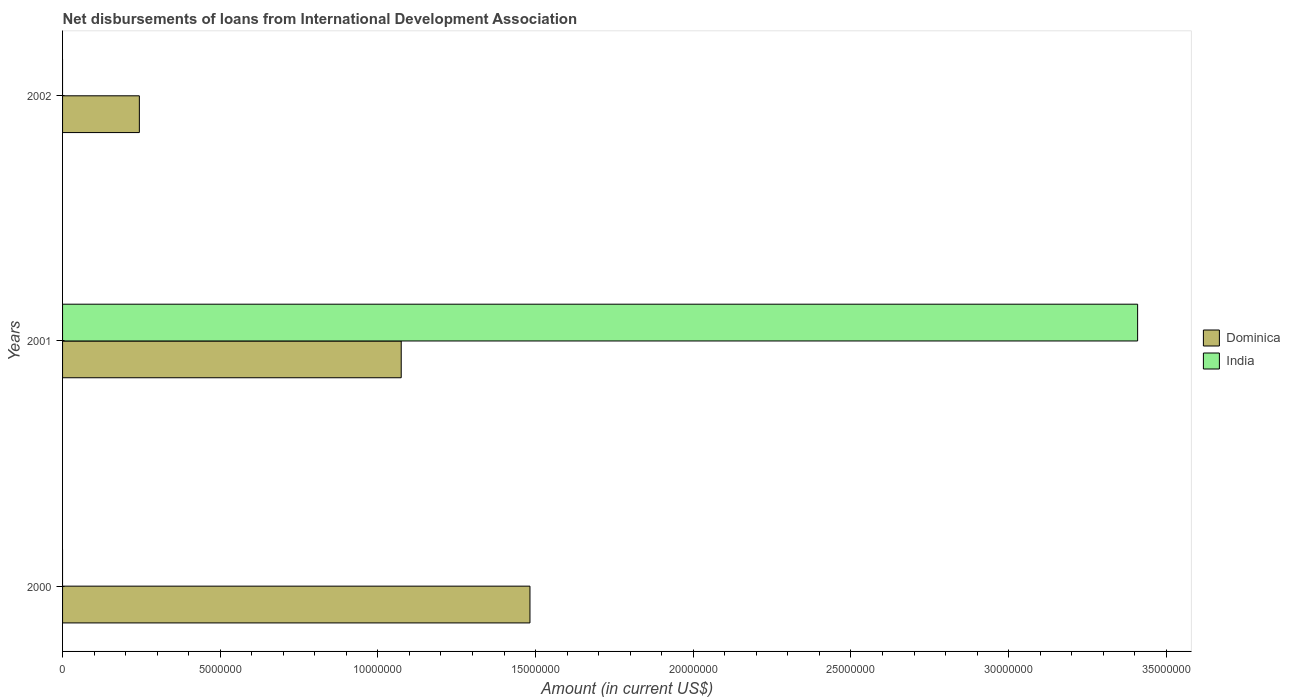How many different coloured bars are there?
Give a very brief answer. 2. How many bars are there on the 2nd tick from the top?
Make the answer very short. 2. What is the amount of loans disbursed in Dominica in 2001?
Provide a succinct answer. 1.07e+07. Across all years, what is the maximum amount of loans disbursed in India?
Ensure brevity in your answer.  3.41e+07. Across all years, what is the minimum amount of loans disbursed in India?
Provide a succinct answer. 0. In which year was the amount of loans disbursed in India maximum?
Your response must be concise. 2001. What is the total amount of loans disbursed in Dominica in the graph?
Make the answer very short. 2.80e+07. What is the difference between the amount of loans disbursed in Dominica in 2000 and that in 2001?
Your answer should be compact. 4.08e+06. What is the difference between the amount of loans disbursed in India in 2001 and the amount of loans disbursed in Dominica in 2002?
Your answer should be compact. 3.17e+07. What is the average amount of loans disbursed in India per year?
Make the answer very short. 1.14e+07. In the year 2001, what is the difference between the amount of loans disbursed in Dominica and amount of loans disbursed in India?
Provide a succinct answer. -2.34e+07. In how many years, is the amount of loans disbursed in Dominica greater than 5000000 US$?
Offer a very short reply. 2. What is the ratio of the amount of loans disbursed in Dominica in 2001 to that in 2002?
Your answer should be compact. 4.41. Is the amount of loans disbursed in Dominica in 2000 less than that in 2002?
Provide a succinct answer. No. What is the difference between the highest and the second highest amount of loans disbursed in Dominica?
Offer a very short reply. 4.08e+06. What is the difference between the highest and the lowest amount of loans disbursed in Dominica?
Offer a terse response. 1.24e+07. In how many years, is the amount of loans disbursed in Dominica greater than the average amount of loans disbursed in Dominica taken over all years?
Give a very brief answer. 2. How many years are there in the graph?
Your answer should be very brief. 3. What is the difference between two consecutive major ticks on the X-axis?
Ensure brevity in your answer.  5.00e+06. Does the graph contain any zero values?
Your answer should be very brief. Yes. Where does the legend appear in the graph?
Ensure brevity in your answer.  Center right. What is the title of the graph?
Your answer should be very brief. Net disbursements of loans from International Development Association. What is the Amount (in current US$) of Dominica in 2000?
Make the answer very short. 1.48e+07. What is the Amount (in current US$) in Dominica in 2001?
Your answer should be very brief. 1.07e+07. What is the Amount (in current US$) in India in 2001?
Offer a very short reply. 3.41e+07. What is the Amount (in current US$) of Dominica in 2002?
Your answer should be compact. 2.44e+06. What is the Amount (in current US$) in India in 2002?
Your response must be concise. 0. Across all years, what is the maximum Amount (in current US$) of Dominica?
Your answer should be compact. 1.48e+07. Across all years, what is the maximum Amount (in current US$) of India?
Offer a very short reply. 3.41e+07. Across all years, what is the minimum Amount (in current US$) in Dominica?
Ensure brevity in your answer.  2.44e+06. What is the total Amount (in current US$) of Dominica in the graph?
Ensure brevity in your answer.  2.80e+07. What is the total Amount (in current US$) of India in the graph?
Provide a succinct answer. 3.41e+07. What is the difference between the Amount (in current US$) in Dominica in 2000 and that in 2001?
Your answer should be very brief. 4.08e+06. What is the difference between the Amount (in current US$) of Dominica in 2000 and that in 2002?
Provide a succinct answer. 1.24e+07. What is the difference between the Amount (in current US$) in Dominica in 2001 and that in 2002?
Provide a short and direct response. 8.30e+06. What is the difference between the Amount (in current US$) in Dominica in 2000 and the Amount (in current US$) in India in 2001?
Keep it short and to the point. -1.93e+07. What is the average Amount (in current US$) in Dominica per year?
Give a very brief answer. 9.33e+06. What is the average Amount (in current US$) of India per year?
Your answer should be compact. 1.14e+07. In the year 2001, what is the difference between the Amount (in current US$) of Dominica and Amount (in current US$) of India?
Offer a very short reply. -2.34e+07. What is the ratio of the Amount (in current US$) in Dominica in 2000 to that in 2001?
Offer a very short reply. 1.38. What is the ratio of the Amount (in current US$) of Dominica in 2000 to that in 2002?
Give a very brief answer. 6.09. What is the ratio of the Amount (in current US$) in Dominica in 2001 to that in 2002?
Offer a terse response. 4.41. What is the difference between the highest and the second highest Amount (in current US$) in Dominica?
Give a very brief answer. 4.08e+06. What is the difference between the highest and the lowest Amount (in current US$) of Dominica?
Provide a short and direct response. 1.24e+07. What is the difference between the highest and the lowest Amount (in current US$) in India?
Your answer should be compact. 3.41e+07. 